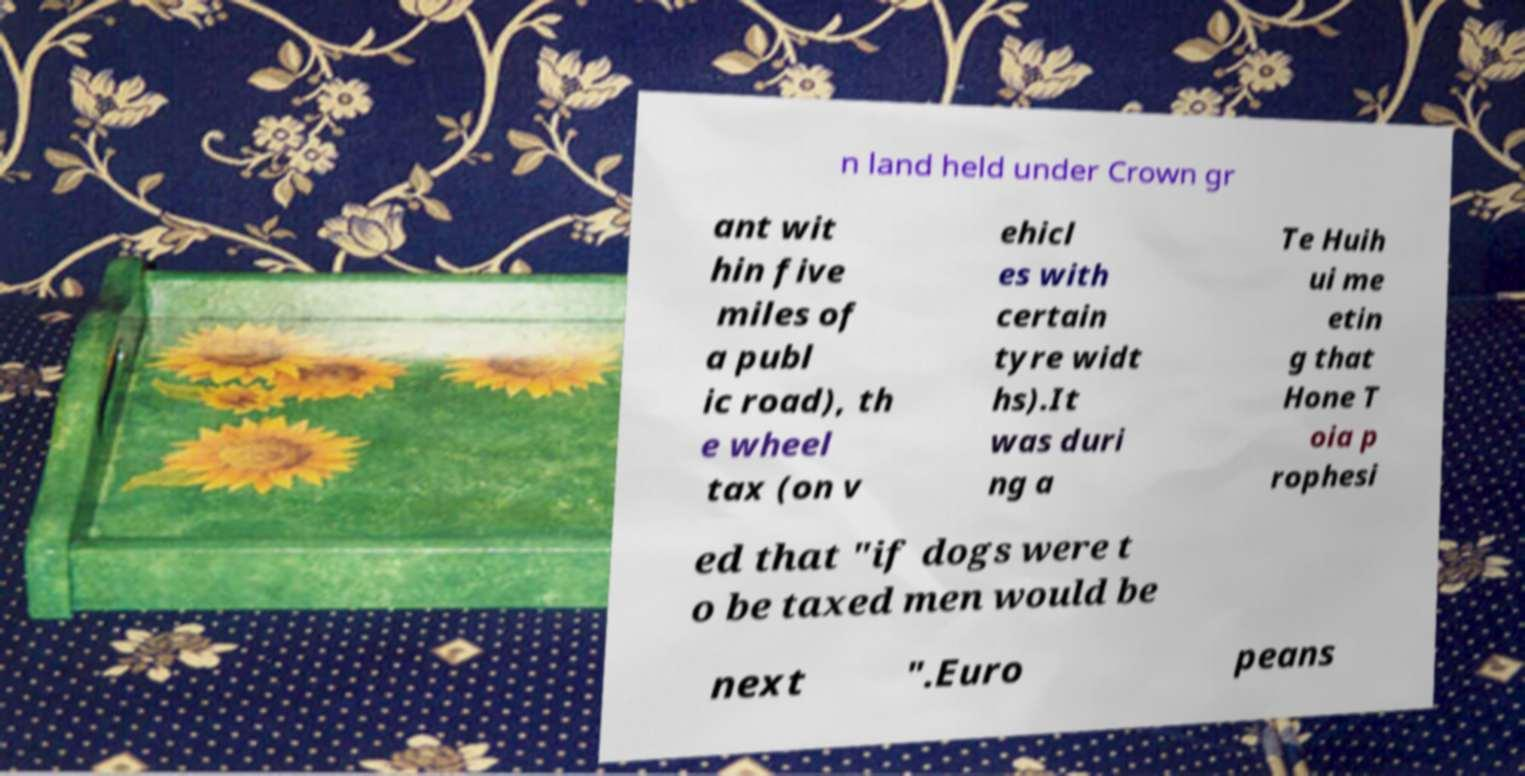I need the written content from this picture converted into text. Can you do that? n land held under Crown gr ant wit hin five miles of a publ ic road), th e wheel tax (on v ehicl es with certain tyre widt hs).It was duri ng a Te Huih ui me etin g that Hone T oia p rophesi ed that "if dogs were t o be taxed men would be next ".Euro peans 